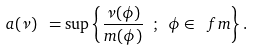<formula> <loc_0><loc_0><loc_500><loc_500>\ a ( \nu ) \ = \sup \left \{ \frac { \nu ( \phi ) } { m ( \phi ) } \ ; \ \phi \in \ f m \right \} .</formula> 